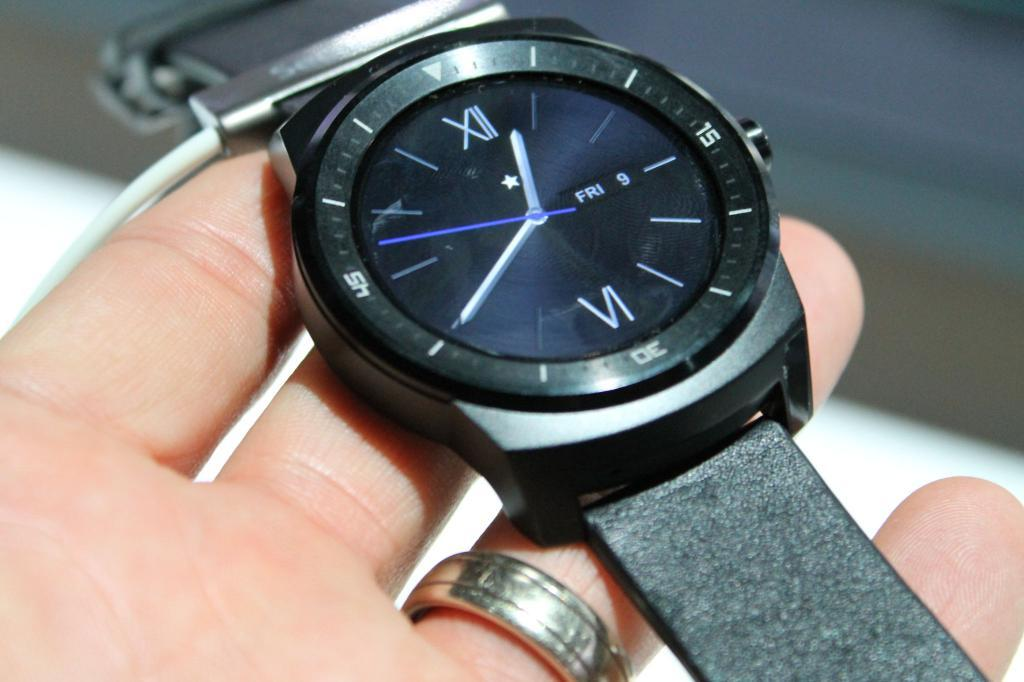<image>
Relay a brief, clear account of the picture shown. Person holding a black wristwatch which says FRI 9 on it., 